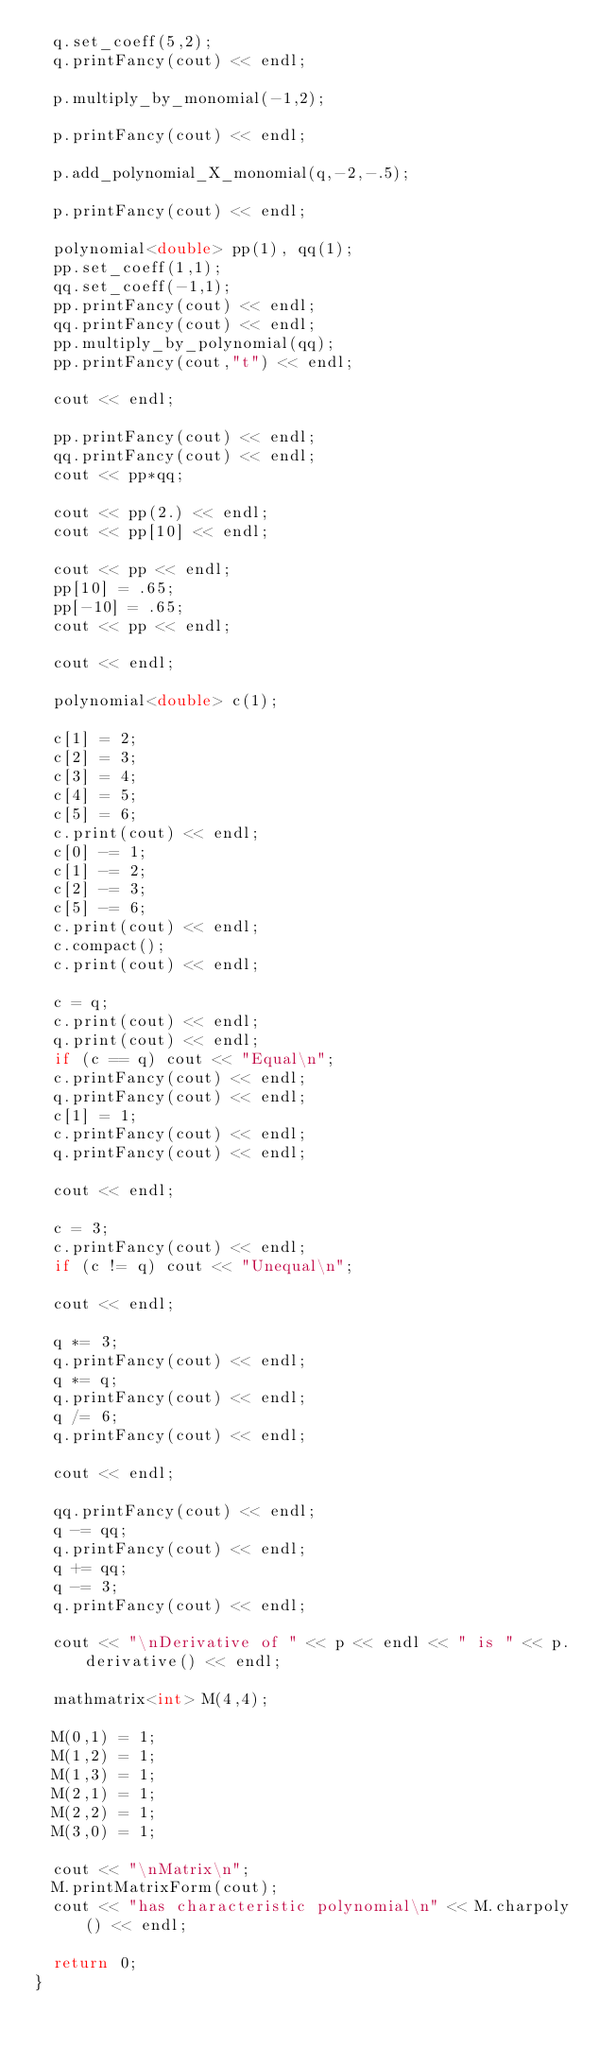Convert code to text. <code><loc_0><loc_0><loc_500><loc_500><_C++_>  q.set_coeff(5,2);
  q.printFancy(cout) << endl;

  p.multiply_by_monomial(-1,2);

  p.printFancy(cout) << endl;

  p.add_polynomial_X_monomial(q,-2,-.5);

  p.printFancy(cout) << endl;

  polynomial<double> pp(1), qq(1);
  pp.set_coeff(1,1);
  qq.set_coeff(-1,1);
  pp.printFancy(cout) << endl;
  qq.printFancy(cout) << endl;
  pp.multiply_by_polynomial(qq);
  pp.printFancy(cout,"t") << endl;

  cout << endl;

  pp.printFancy(cout) << endl;
  qq.printFancy(cout) << endl;
  cout << pp*qq;

  cout << pp(2.) << endl;
  cout << pp[10] << endl;

  cout << pp << endl;
  pp[10] = .65;
  pp[-10] = .65;
  cout << pp << endl;

  cout << endl;

  polynomial<double> c(1);

  c[1] = 2;
  c[2] = 3;
  c[3] = 4;
  c[4] = 5;
  c[5] = 6;
  c.print(cout) << endl;
  c[0] -= 1;
  c[1] -= 2;
  c[2] -= 3;
  c[5] -= 6;
  c.print(cout) << endl;
  c.compact();
  c.print(cout) << endl;

  c = q;
  c.print(cout) << endl;
  q.print(cout) << endl;
  if (c == q) cout << "Equal\n";
  c.printFancy(cout) << endl;
  q.printFancy(cout) << endl;
  c[1] = 1;
  c.printFancy(cout) << endl;
  q.printFancy(cout) << endl;

  cout << endl;

  c = 3;
  c.printFancy(cout) << endl;
  if (c != q) cout << "Unequal\n";

  cout << endl;

  q *= 3;
  q.printFancy(cout) << endl;
  q *= q;
  q.printFancy(cout) << endl;
  q /= 6;
  q.printFancy(cout) << endl;

  cout << endl;

  qq.printFancy(cout) << endl;
  q -= qq;
  q.printFancy(cout) << endl;
  q += qq;
  q -= 3;
  q.printFancy(cout) << endl;

  cout << "\nDerivative of " << p << endl << " is " << p.derivative() << endl;

  mathmatrix<int> M(4,4);

  M(0,1) = 1;
  M(1,2) = 1;
  M(1,3) = 1;
  M(2,1) = 1;
  M(2,2) = 1;
  M(3,0) = 1;

  cout << "\nMatrix\n";
  M.printMatrixForm(cout);
  cout << "has characteristic polynomial\n" << M.charpoly() << endl;

  return 0;
}
</code> 